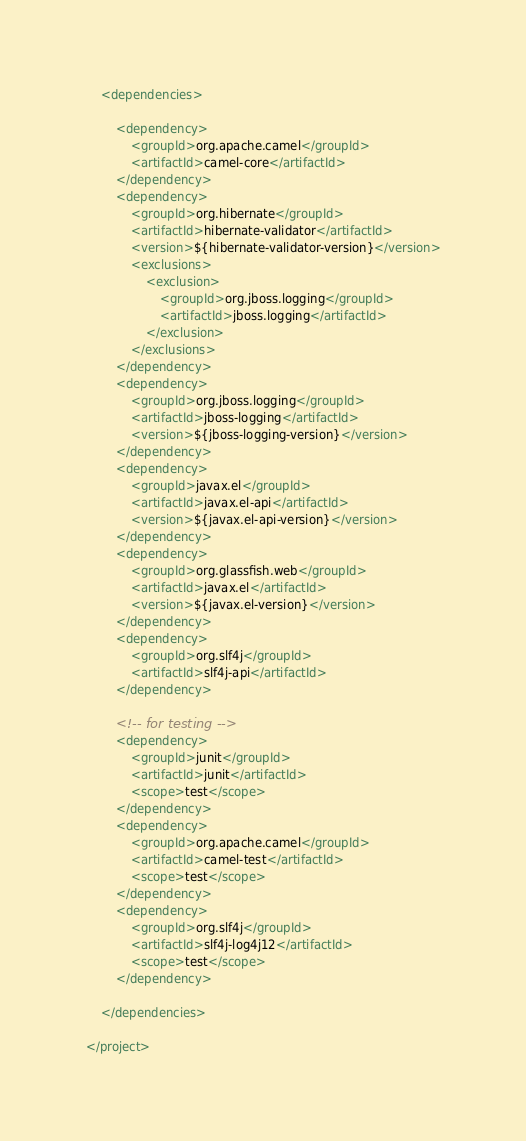Convert code to text. <code><loc_0><loc_0><loc_500><loc_500><_XML_>
    <dependencies>

        <dependency>
            <groupId>org.apache.camel</groupId>
            <artifactId>camel-core</artifactId>
        </dependency>
        <dependency>
            <groupId>org.hibernate</groupId>
            <artifactId>hibernate-validator</artifactId>
            <version>${hibernate-validator-version}</version>
            <exclusions>
                <exclusion>
                    <groupId>org.jboss.logging</groupId>
                    <artifactId>jboss.logging</artifactId>
                </exclusion>
            </exclusions>
        </dependency>
        <dependency>
            <groupId>org.jboss.logging</groupId>
            <artifactId>jboss-logging</artifactId>
            <version>${jboss-logging-version}</version>
        </dependency>
        <dependency>
            <groupId>javax.el</groupId>
            <artifactId>javax.el-api</artifactId>
            <version>${javax.el-api-version}</version>
        </dependency>
        <dependency>
            <groupId>org.glassfish.web</groupId>
            <artifactId>javax.el</artifactId>
            <version>${javax.el-version}</version>
        </dependency>
        <dependency>
            <groupId>org.slf4j</groupId>
            <artifactId>slf4j-api</artifactId>
        </dependency>

        <!-- for testing -->
        <dependency>
            <groupId>junit</groupId>
            <artifactId>junit</artifactId>
            <scope>test</scope>
        </dependency>
        <dependency>
            <groupId>org.apache.camel</groupId>
            <artifactId>camel-test</artifactId>
            <scope>test</scope>
        </dependency>
        <dependency>
            <groupId>org.slf4j</groupId>
            <artifactId>slf4j-log4j12</artifactId>
            <scope>test</scope>
        </dependency>

    </dependencies>

</project>
</code> 